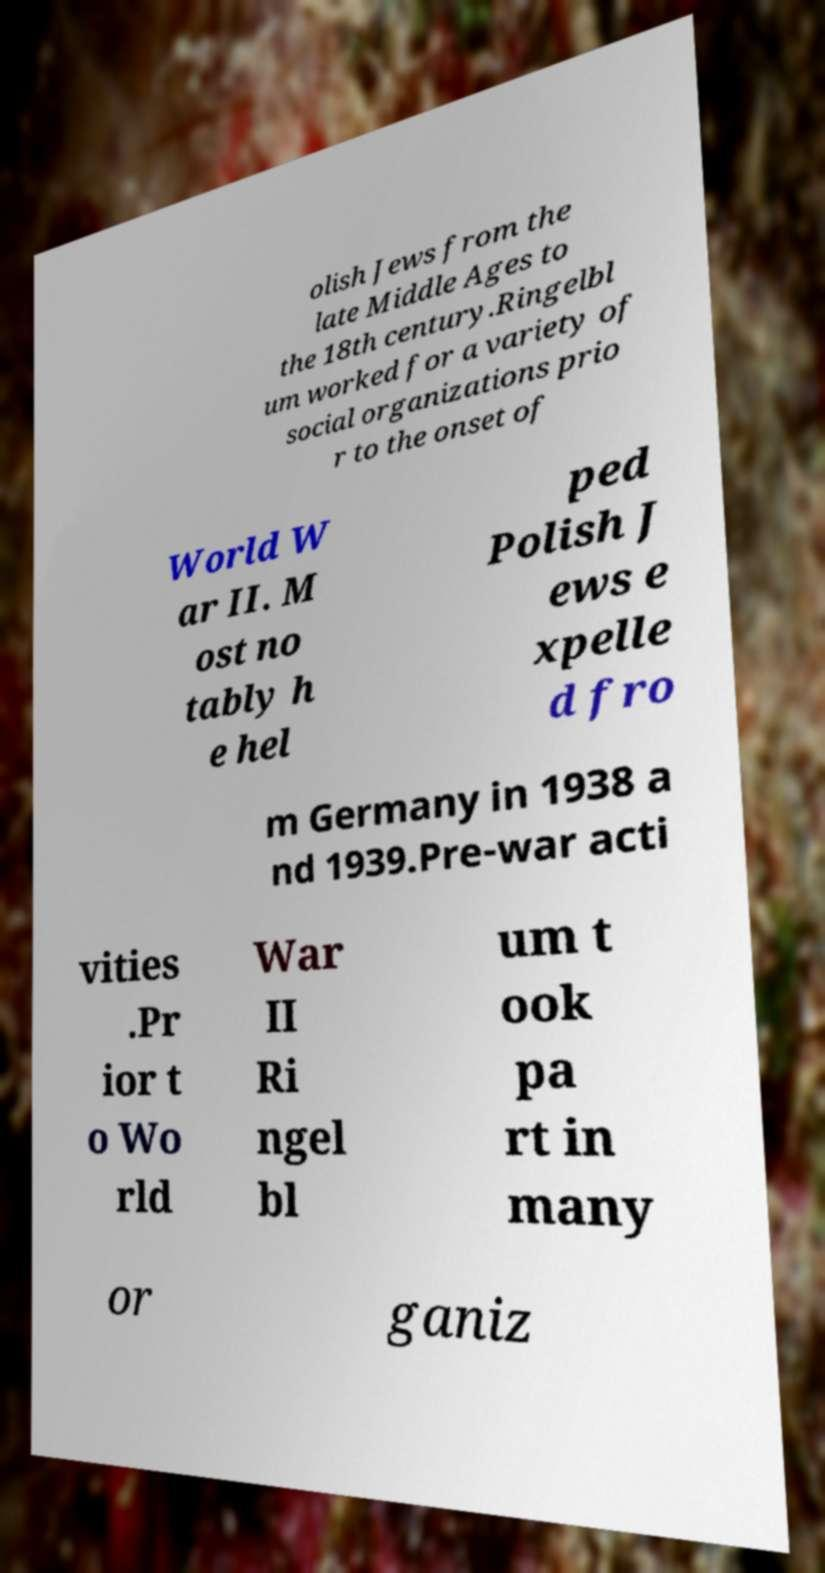Please read and relay the text visible in this image. What does it say? olish Jews from the late Middle Ages to the 18th century.Ringelbl um worked for a variety of social organizations prio r to the onset of World W ar II. M ost no tably h e hel ped Polish J ews e xpelle d fro m Germany in 1938 a nd 1939.Pre-war acti vities .Pr ior t o Wo rld War II Ri ngel bl um t ook pa rt in many or ganiz 